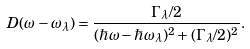<formula> <loc_0><loc_0><loc_500><loc_500>D ( \omega - \omega _ { \lambda } ) = \frac { \Gamma _ { \lambda } / 2 } { ( \hbar { \omega } - \hbar { \omega } _ { \lambda } ) ^ { 2 } + ( \Gamma _ { \lambda } / 2 ) ^ { 2 } } .</formula> 